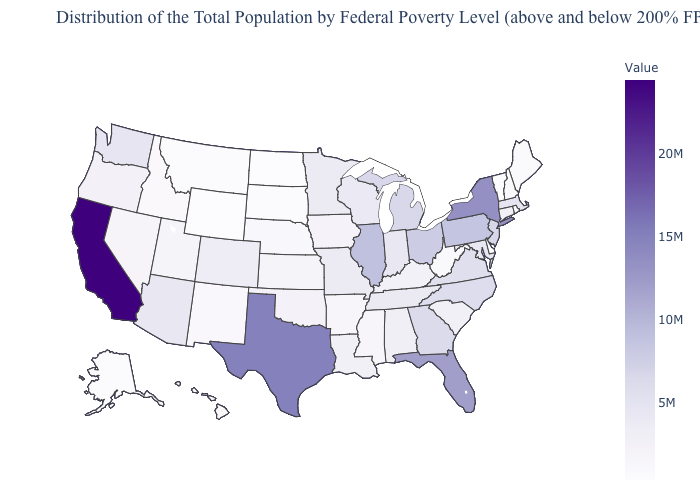Which states have the lowest value in the MidWest?
Short answer required. North Dakota. Which states have the highest value in the USA?
Be succinct. California. Does Delaware have the lowest value in the South?
Quick response, please. Yes. Does Florida have a lower value than Texas?
Give a very brief answer. Yes. Among the states that border Maine , which have the lowest value?
Keep it brief. New Hampshire. Among the states that border New Hampshire , which have the lowest value?
Be succinct. Vermont. 